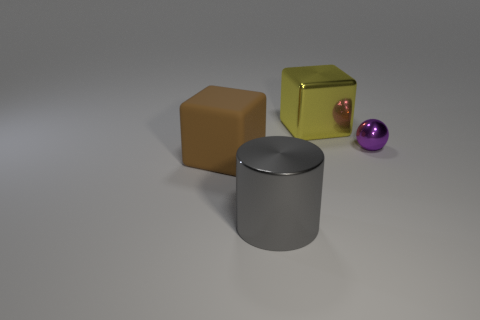There is a object on the right side of the cube that is right of the large cube that is on the left side of the metal block; what is its shape?
Your response must be concise. Sphere. What is the color of the thing in front of the brown object?
Keep it short and to the point. Gray. How many things are things that are in front of the yellow object or large objects that are in front of the large yellow metallic thing?
Offer a very short reply. 3. How many large yellow metal objects are the same shape as the big brown matte object?
Your answer should be compact. 1. There is a cylinder that is the same size as the matte thing; what color is it?
Provide a succinct answer. Gray. What is the color of the thing that is in front of the block that is on the left side of the big yellow block behind the gray shiny cylinder?
Offer a terse response. Gray. There is a gray shiny thing; is its size the same as the thing that is behind the purple metal sphere?
Your answer should be compact. Yes. What number of things are tiny shiny spheres or gray metallic cylinders?
Offer a terse response. 2. Is there a big yellow object that has the same material as the tiny sphere?
Give a very brief answer. Yes. What color is the large object behind the metal thing that is to the right of the yellow metallic object?
Give a very brief answer. Yellow. 